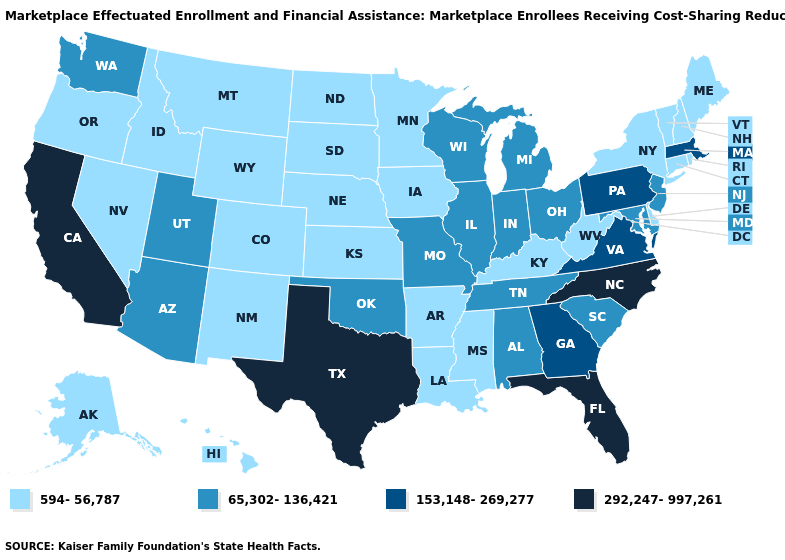Does the first symbol in the legend represent the smallest category?
Give a very brief answer. Yes. Does Vermont have the same value as Idaho?
Keep it brief. Yes. Name the states that have a value in the range 594-56,787?
Keep it brief. Alaska, Arkansas, Colorado, Connecticut, Delaware, Hawaii, Idaho, Iowa, Kansas, Kentucky, Louisiana, Maine, Minnesota, Mississippi, Montana, Nebraska, Nevada, New Hampshire, New Mexico, New York, North Dakota, Oregon, Rhode Island, South Dakota, Vermont, West Virginia, Wyoming. Which states have the lowest value in the West?
Write a very short answer. Alaska, Colorado, Hawaii, Idaho, Montana, Nevada, New Mexico, Oregon, Wyoming. What is the value of Oklahoma?
Concise answer only. 65,302-136,421. Among the states that border Nebraska , which have the lowest value?
Concise answer only. Colorado, Iowa, Kansas, South Dakota, Wyoming. Does New York have the same value as Alabama?
Be succinct. No. What is the lowest value in the Northeast?
Quick response, please. 594-56,787. Which states have the highest value in the USA?
Give a very brief answer. California, Florida, North Carolina, Texas. What is the value of Maryland?
Answer briefly. 65,302-136,421. What is the highest value in the USA?
Be succinct. 292,247-997,261. Name the states that have a value in the range 65,302-136,421?
Keep it brief. Alabama, Arizona, Illinois, Indiana, Maryland, Michigan, Missouri, New Jersey, Ohio, Oklahoma, South Carolina, Tennessee, Utah, Washington, Wisconsin. Does the map have missing data?
Give a very brief answer. No. What is the lowest value in the USA?
Concise answer only. 594-56,787. Among the states that border Louisiana , does Mississippi have the highest value?
Keep it brief. No. 